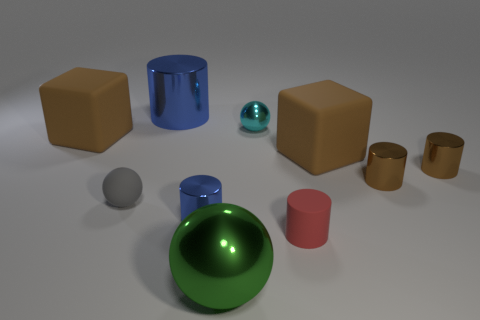Subtract all brown cubes. How many were subtracted if there are1brown cubes left? 1 Subtract all tiny metal balls. How many balls are left? 2 Subtract all red cylinders. How many cylinders are left? 4 Subtract 4 cylinders. How many cylinders are left? 1 Subtract all spheres. How many objects are left? 7 Subtract 0 brown balls. How many objects are left? 10 Subtract all brown spheres. Subtract all gray cylinders. How many spheres are left? 3 Subtract all gray spheres. How many red cylinders are left? 1 Subtract all tiny spheres. Subtract all small gray matte things. How many objects are left? 7 Add 8 tiny rubber cylinders. How many tiny rubber cylinders are left? 9 